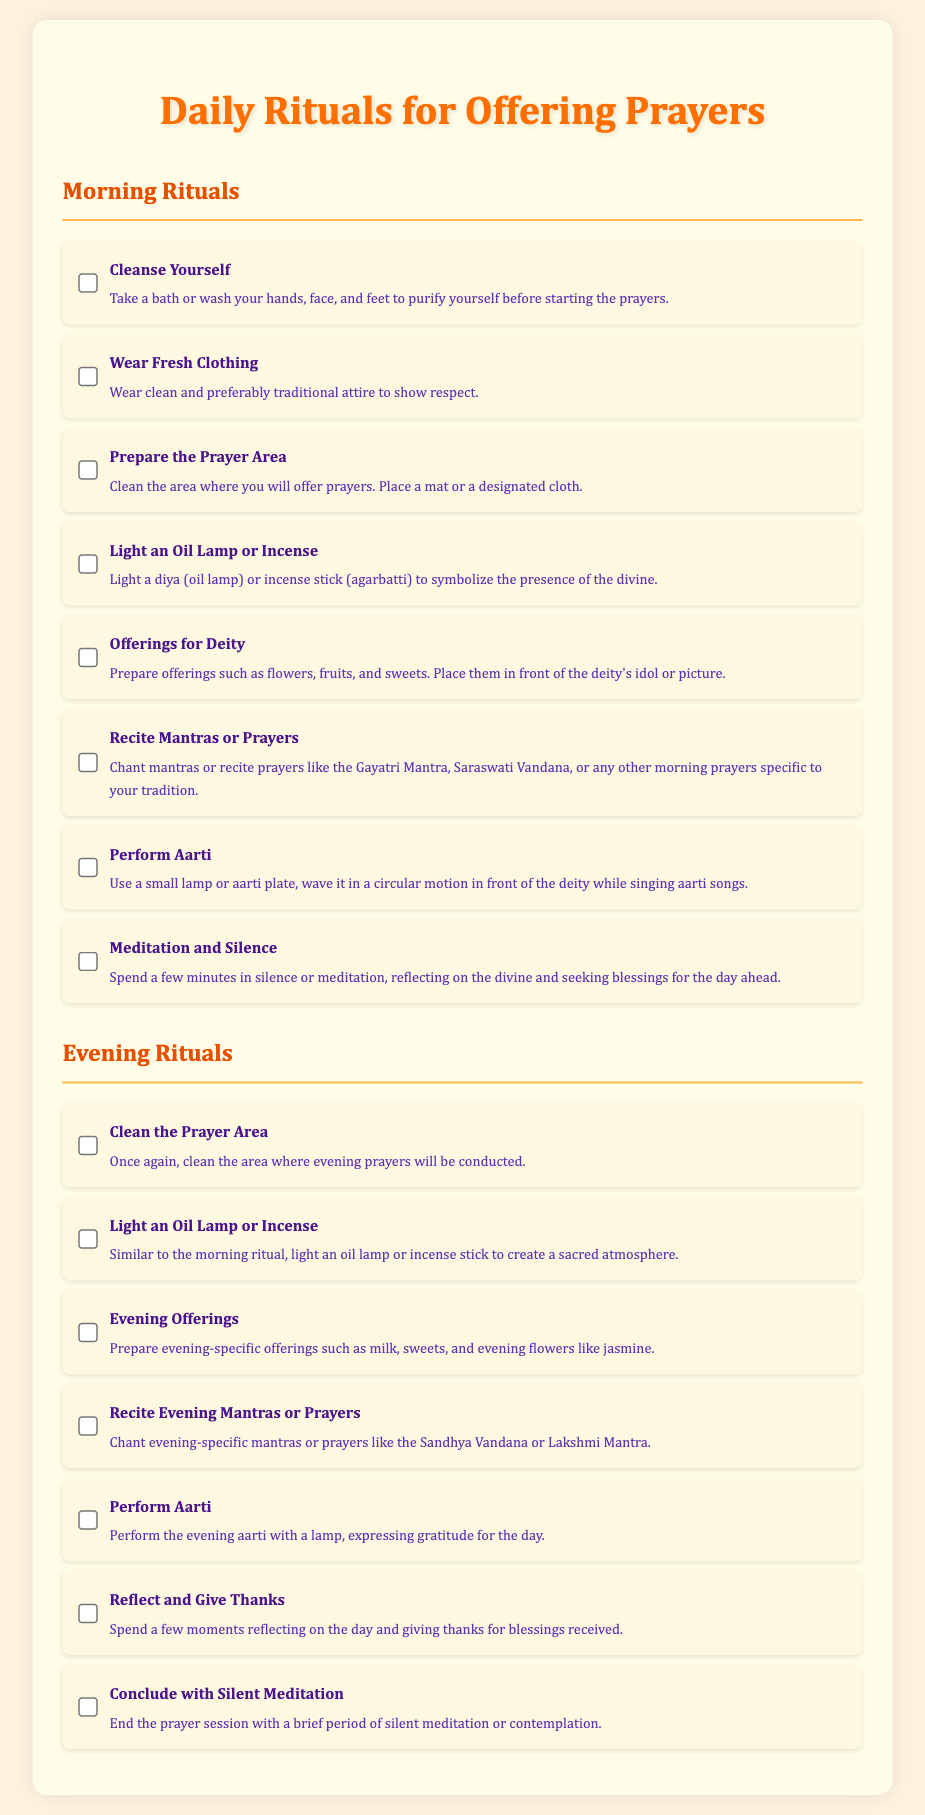What is the title of the document? The title of the document is prominently displayed at the top, indicating the subject of the checklist.
Answer: Daily Rituals for Offering Prayers How many morning rituals are listed? The document provides a numbered list of rituals specifically divided into morning practices.
Answer: Eight What is the first item in the morning rituals? The first item in the morning rituals is specified as the initial step to prepare for prayers.
Answer: Cleanse Yourself What type of clothing should be worn during morning prayers? The document describes the type of attire recommended to show respect during the morning rituals.
Answer: Fresh Clothing Which offering is mentioned for evening rituals? The evening rituals include specific offerings mentioned to be prepared and presented during the evening prayers.
Answer: Milk, sweets, and evening flowers What duration does the document suggest for meditation at the end of evening prayers? The document indicates a brief period designated for meditation at the conclusion of the evening rituals.
Answer: Brief What is the purpose of lighting an oil lamp or incense? This ritual's purpose is indicated as a way to create a sacred atmosphere during the prayer practices.
Answer: Symbolize the presence of the divine How should the prayer area be prepared for evening rituals? The document instructs on the cleaning process required before evening prayers are performed in the designated area.
Answer: Clean the Prayer Area 